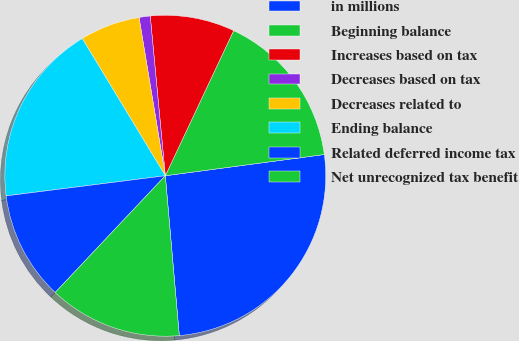Convert chart to OTSL. <chart><loc_0><loc_0><loc_500><loc_500><pie_chart><fcel>in millions<fcel>Beginning balance<fcel>Increases based on tax<fcel>Decreases based on tax<fcel>Decreases related to<fcel>Ending balance<fcel>Related deferred income tax<fcel>Net unrecognized tax benefit<nl><fcel>25.72%<fcel>15.88%<fcel>8.5%<fcel>1.12%<fcel>6.04%<fcel>18.34%<fcel>10.96%<fcel>13.42%<nl></chart> 